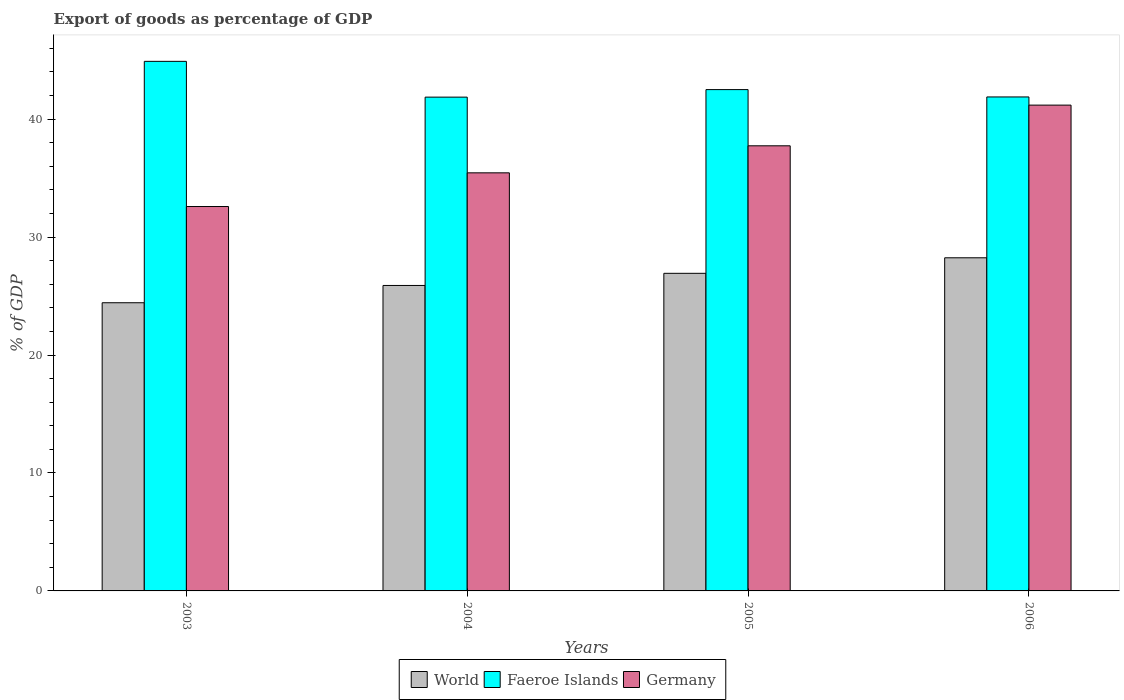What is the export of goods as percentage of GDP in Germany in 2004?
Ensure brevity in your answer.  35.45. Across all years, what is the maximum export of goods as percentage of GDP in World?
Keep it short and to the point. 28.24. Across all years, what is the minimum export of goods as percentage of GDP in Germany?
Provide a succinct answer. 32.59. In which year was the export of goods as percentage of GDP in Faeroe Islands minimum?
Your answer should be compact. 2004. What is the total export of goods as percentage of GDP in World in the graph?
Your answer should be very brief. 105.51. What is the difference between the export of goods as percentage of GDP in Germany in 2004 and that in 2005?
Your answer should be compact. -2.29. What is the difference between the export of goods as percentage of GDP in Germany in 2003 and the export of goods as percentage of GDP in World in 2006?
Your answer should be very brief. 4.35. What is the average export of goods as percentage of GDP in Germany per year?
Give a very brief answer. 36.74. In the year 2003, what is the difference between the export of goods as percentage of GDP in Germany and export of goods as percentage of GDP in World?
Keep it short and to the point. 8.16. What is the ratio of the export of goods as percentage of GDP in World in 2003 to that in 2004?
Keep it short and to the point. 0.94. Is the export of goods as percentage of GDP in Faeroe Islands in 2003 less than that in 2004?
Provide a short and direct response. No. What is the difference between the highest and the second highest export of goods as percentage of GDP in World?
Offer a very short reply. 1.32. What is the difference between the highest and the lowest export of goods as percentage of GDP in World?
Your answer should be very brief. 3.81. In how many years, is the export of goods as percentage of GDP in World greater than the average export of goods as percentage of GDP in World taken over all years?
Ensure brevity in your answer.  2. What does the 2nd bar from the right in 2003 represents?
Provide a succinct answer. Faeroe Islands. Are all the bars in the graph horizontal?
Offer a terse response. No. Are the values on the major ticks of Y-axis written in scientific E-notation?
Make the answer very short. No. Does the graph contain any zero values?
Ensure brevity in your answer.  No. Does the graph contain grids?
Give a very brief answer. No. Where does the legend appear in the graph?
Make the answer very short. Bottom center. How many legend labels are there?
Make the answer very short. 3. What is the title of the graph?
Offer a terse response. Export of goods as percentage of GDP. Does "Bahamas" appear as one of the legend labels in the graph?
Your answer should be very brief. No. What is the label or title of the Y-axis?
Provide a short and direct response. % of GDP. What is the % of GDP of World in 2003?
Provide a short and direct response. 24.43. What is the % of GDP of Faeroe Islands in 2003?
Your answer should be compact. 44.9. What is the % of GDP of Germany in 2003?
Your response must be concise. 32.59. What is the % of GDP in World in 2004?
Your response must be concise. 25.9. What is the % of GDP of Faeroe Islands in 2004?
Keep it short and to the point. 41.87. What is the % of GDP of Germany in 2004?
Keep it short and to the point. 35.45. What is the % of GDP of World in 2005?
Give a very brief answer. 26.93. What is the % of GDP of Faeroe Islands in 2005?
Your answer should be compact. 42.5. What is the % of GDP of Germany in 2005?
Offer a very short reply. 37.74. What is the % of GDP in World in 2006?
Your answer should be compact. 28.24. What is the % of GDP in Faeroe Islands in 2006?
Offer a terse response. 41.88. What is the % of GDP in Germany in 2006?
Make the answer very short. 41.19. Across all years, what is the maximum % of GDP in World?
Provide a short and direct response. 28.24. Across all years, what is the maximum % of GDP of Faeroe Islands?
Provide a short and direct response. 44.9. Across all years, what is the maximum % of GDP of Germany?
Your answer should be compact. 41.19. Across all years, what is the minimum % of GDP of World?
Offer a very short reply. 24.43. Across all years, what is the minimum % of GDP of Faeroe Islands?
Give a very brief answer. 41.87. Across all years, what is the minimum % of GDP of Germany?
Your answer should be compact. 32.59. What is the total % of GDP in World in the graph?
Offer a terse response. 105.51. What is the total % of GDP in Faeroe Islands in the graph?
Make the answer very short. 171.16. What is the total % of GDP of Germany in the graph?
Provide a short and direct response. 146.97. What is the difference between the % of GDP in World in 2003 and that in 2004?
Provide a succinct answer. -1.47. What is the difference between the % of GDP in Faeroe Islands in 2003 and that in 2004?
Ensure brevity in your answer.  3.03. What is the difference between the % of GDP in Germany in 2003 and that in 2004?
Your response must be concise. -2.86. What is the difference between the % of GDP of World in 2003 and that in 2005?
Offer a terse response. -2.49. What is the difference between the % of GDP of Faeroe Islands in 2003 and that in 2005?
Ensure brevity in your answer.  2.4. What is the difference between the % of GDP of Germany in 2003 and that in 2005?
Ensure brevity in your answer.  -5.15. What is the difference between the % of GDP of World in 2003 and that in 2006?
Keep it short and to the point. -3.81. What is the difference between the % of GDP of Faeroe Islands in 2003 and that in 2006?
Your answer should be compact. 3.02. What is the difference between the % of GDP of Germany in 2003 and that in 2006?
Give a very brief answer. -8.6. What is the difference between the % of GDP of World in 2004 and that in 2005?
Keep it short and to the point. -1.03. What is the difference between the % of GDP in Faeroe Islands in 2004 and that in 2005?
Offer a very short reply. -0.64. What is the difference between the % of GDP in Germany in 2004 and that in 2005?
Your answer should be very brief. -2.29. What is the difference between the % of GDP of World in 2004 and that in 2006?
Offer a very short reply. -2.35. What is the difference between the % of GDP in Faeroe Islands in 2004 and that in 2006?
Ensure brevity in your answer.  -0.02. What is the difference between the % of GDP in Germany in 2004 and that in 2006?
Your answer should be very brief. -5.74. What is the difference between the % of GDP of World in 2005 and that in 2006?
Offer a very short reply. -1.32. What is the difference between the % of GDP of Faeroe Islands in 2005 and that in 2006?
Your answer should be compact. 0.62. What is the difference between the % of GDP in Germany in 2005 and that in 2006?
Give a very brief answer. -3.45. What is the difference between the % of GDP of World in 2003 and the % of GDP of Faeroe Islands in 2004?
Offer a very short reply. -17.43. What is the difference between the % of GDP in World in 2003 and the % of GDP in Germany in 2004?
Your answer should be very brief. -11.01. What is the difference between the % of GDP in Faeroe Islands in 2003 and the % of GDP in Germany in 2004?
Keep it short and to the point. 9.45. What is the difference between the % of GDP of World in 2003 and the % of GDP of Faeroe Islands in 2005?
Offer a terse response. -18.07. What is the difference between the % of GDP in World in 2003 and the % of GDP in Germany in 2005?
Your answer should be very brief. -13.31. What is the difference between the % of GDP in Faeroe Islands in 2003 and the % of GDP in Germany in 2005?
Provide a succinct answer. 7.16. What is the difference between the % of GDP in World in 2003 and the % of GDP in Faeroe Islands in 2006?
Your answer should be compact. -17.45. What is the difference between the % of GDP in World in 2003 and the % of GDP in Germany in 2006?
Your answer should be compact. -16.76. What is the difference between the % of GDP in Faeroe Islands in 2003 and the % of GDP in Germany in 2006?
Your answer should be compact. 3.71. What is the difference between the % of GDP of World in 2004 and the % of GDP of Faeroe Islands in 2005?
Ensure brevity in your answer.  -16.61. What is the difference between the % of GDP of World in 2004 and the % of GDP of Germany in 2005?
Your answer should be very brief. -11.84. What is the difference between the % of GDP of Faeroe Islands in 2004 and the % of GDP of Germany in 2005?
Keep it short and to the point. 4.13. What is the difference between the % of GDP of World in 2004 and the % of GDP of Faeroe Islands in 2006?
Your answer should be very brief. -15.98. What is the difference between the % of GDP of World in 2004 and the % of GDP of Germany in 2006?
Make the answer very short. -15.29. What is the difference between the % of GDP of Faeroe Islands in 2004 and the % of GDP of Germany in 2006?
Your answer should be very brief. 0.68. What is the difference between the % of GDP of World in 2005 and the % of GDP of Faeroe Islands in 2006?
Ensure brevity in your answer.  -14.95. What is the difference between the % of GDP of World in 2005 and the % of GDP of Germany in 2006?
Provide a succinct answer. -14.26. What is the difference between the % of GDP in Faeroe Islands in 2005 and the % of GDP in Germany in 2006?
Give a very brief answer. 1.31. What is the average % of GDP of World per year?
Your answer should be very brief. 26.38. What is the average % of GDP of Faeroe Islands per year?
Your answer should be very brief. 42.79. What is the average % of GDP of Germany per year?
Offer a very short reply. 36.74. In the year 2003, what is the difference between the % of GDP of World and % of GDP of Faeroe Islands?
Offer a very short reply. -20.47. In the year 2003, what is the difference between the % of GDP in World and % of GDP in Germany?
Offer a terse response. -8.16. In the year 2003, what is the difference between the % of GDP of Faeroe Islands and % of GDP of Germany?
Offer a terse response. 12.31. In the year 2004, what is the difference between the % of GDP in World and % of GDP in Faeroe Islands?
Ensure brevity in your answer.  -15.97. In the year 2004, what is the difference between the % of GDP in World and % of GDP in Germany?
Offer a very short reply. -9.55. In the year 2004, what is the difference between the % of GDP of Faeroe Islands and % of GDP of Germany?
Provide a succinct answer. 6.42. In the year 2005, what is the difference between the % of GDP in World and % of GDP in Faeroe Islands?
Give a very brief answer. -15.58. In the year 2005, what is the difference between the % of GDP of World and % of GDP of Germany?
Your answer should be compact. -10.81. In the year 2005, what is the difference between the % of GDP of Faeroe Islands and % of GDP of Germany?
Your answer should be compact. 4.76. In the year 2006, what is the difference between the % of GDP in World and % of GDP in Faeroe Islands?
Provide a short and direct response. -13.64. In the year 2006, what is the difference between the % of GDP of World and % of GDP of Germany?
Your answer should be compact. -12.95. In the year 2006, what is the difference between the % of GDP in Faeroe Islands and % of GDP in Germany?
Ensure brevity in your answer.  0.69. What is the ratio of the % of GDP in World in 2003 to that in 2004?
Keep it short and to the point. 0.94. What is the ratio of the % of GDP of Faeroe Islands in 2003 to that in 2004?
Keep it short and to the point. 1.07. What is the ratio of the % of GDP in Germany in 2003 to that in 2004?
Provide a short and direct response. 0.92. What is the ratio of the % of GDP in World in 2003 to that in 2005?
Keep it short and to the point. 0.91. What is the ratio of the % of GDP of Faeroe Islands in 2003 to that in 2005?
Your answer should be very brief. 1.06. What is the ratio of the % of GDP of Germany in 2003 to that in 2005?
Keep it short and to the point. 0.86. What is the ratio of the % of GDP in World in 2003 to that in 2006?
Offer a very short reply. 0.87. What is the ratio of the % of GDP in Faeroe Islands in 2003 to that in 2006?
Offer a terse response. 1.07. What is the ratio of the % of GDP in Germany in 2003 to that in 2006?
Offer a very short reply. 0.79. What is the ratio of the % of GDP in World in 2004 to that in 2005?
Offer a terse response. 0.96. What is the ratio of the % of GDP of Faeroe Islands in 2004 to that in 2005?
Keep it short and to the point. 0.98. What is the ratio of the % of GDP of Germany in 2004 to that in 2005?
Keep it short and to the point. 0.94. What is the ratio of the % of GDP of World in 2004 to that in 2006?
Keep it short and to the point. 0.92. What is the ratio of the % of GDP in Faeroe Islands in 2004 to that in 2006?
Make the answer very short. 1. What is the ratio of the % of GDP in Germany in 2004 to that in 2006?
Offer a very short reply. 0.86. What is the ratio of the % of GDP of World in 2005 to that in 2006?
Offer a terse response. 0.95. What is the ratio of the % of GDP in Faeroe Islands in 2005 to that in 2006?
Ensure brevity in your answer.  1.01. What is the ratio of the % of GDP in Germany in 2005 to that in 2006?
Offer a very short reply. 0.92. What is the difference between the highest and the second highest % of GDP in World?
Offer a terse response. 1.32. What is the difference between the highest and the second highest % of GDP of Faeroe Islands?
Your answer should be very brief. 2.4. What is the difference between the highest and the second highest % of GDP in Germany?
Make the answer very short. 3.45. What is the difference between the highest and the lowest % of GDP of World?
Provide a succinct answer. 3.81. What is the difference between the highest and the lowest % of GDP of Faeroe Islands?
Your answer should be very brief. 3.03. What is the difference between the highest and the lowest % of GDP in Germany?
Your answer should be compact. 8.6. 